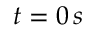<formula> <loc_0><loc_0><loc_500><loc_500>t = 0 \, s</formula> 